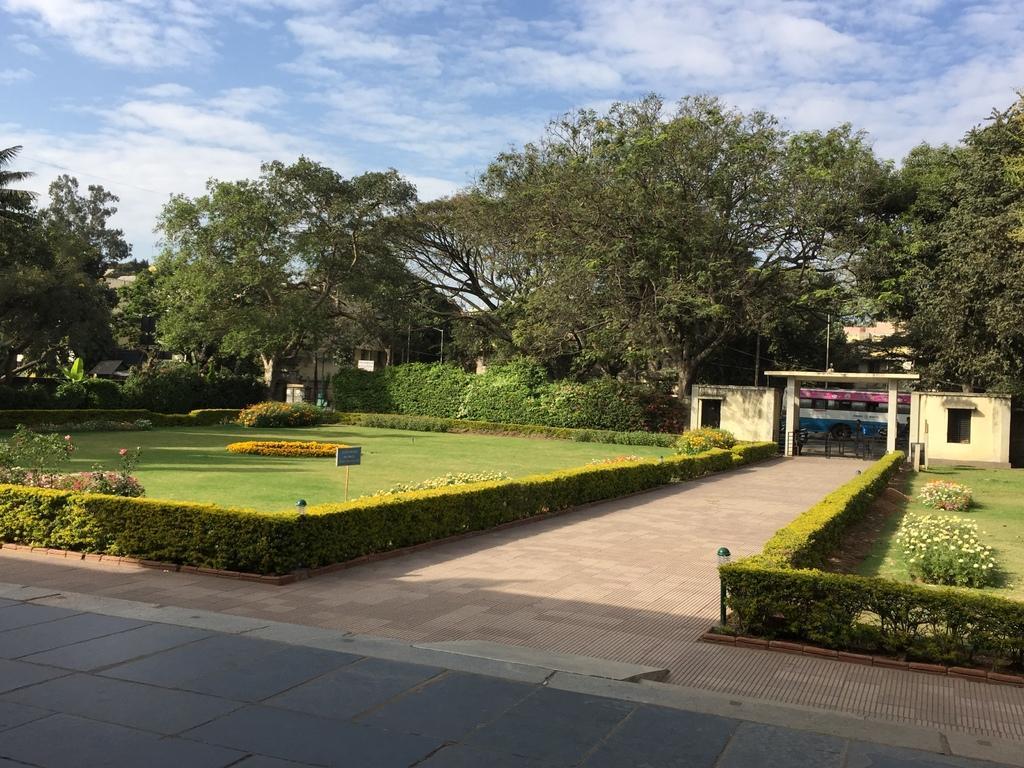Could you give a brief overview of what you see in this image? These are the trees with branches and leaves. I can see the small bushes and the plants with flowers. This looks like a board attached to the pole. Here is the gate. This is an arch. I can see the bus on the road. I think these are the rooms with the windows. 